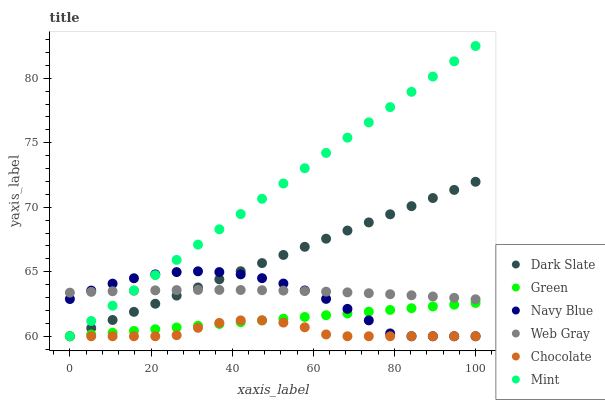Does Chocolate have the minimum area under the curve?
Answer yes or no. Yes. Does Mint have the maximum area under the curve?
Answer yes or no. Yes. Does Navy Blue have the minimum area under the curve?
Answer yes or no. No. Does Navy Blue have the maximum area under the curve?
Answer yes or no. No. Is Green the smoothest?
Answer yes or no. Yes. Is Navy Blue the roughest?
Answer yes or no. Yes. Is Chocolate the smoothest?
Answer yes or no. No. Is Chocolate the roughest?
Answer yes or no. No. Does Navy Blue have the lowest value?
Answer yes or no. Yes. Does Mint have the highest value?
Answer yes or no. Yes. Does Navy Blue have the highest value?
Answer yes or no. No. Is Green less than Web Gray?
Answer yes or no. Yes. Is Web Gray greater than Chocolate?
Answer yes or no. Yes. Does Green intersect Mint?
Answer yes or no. Yes. Is Green less than Mint?
Answer yes or no. No. Is Green greater than Mint?
Answer yes or no. No. Does Green intersect Web Gray?
Answer yes or no. No. 